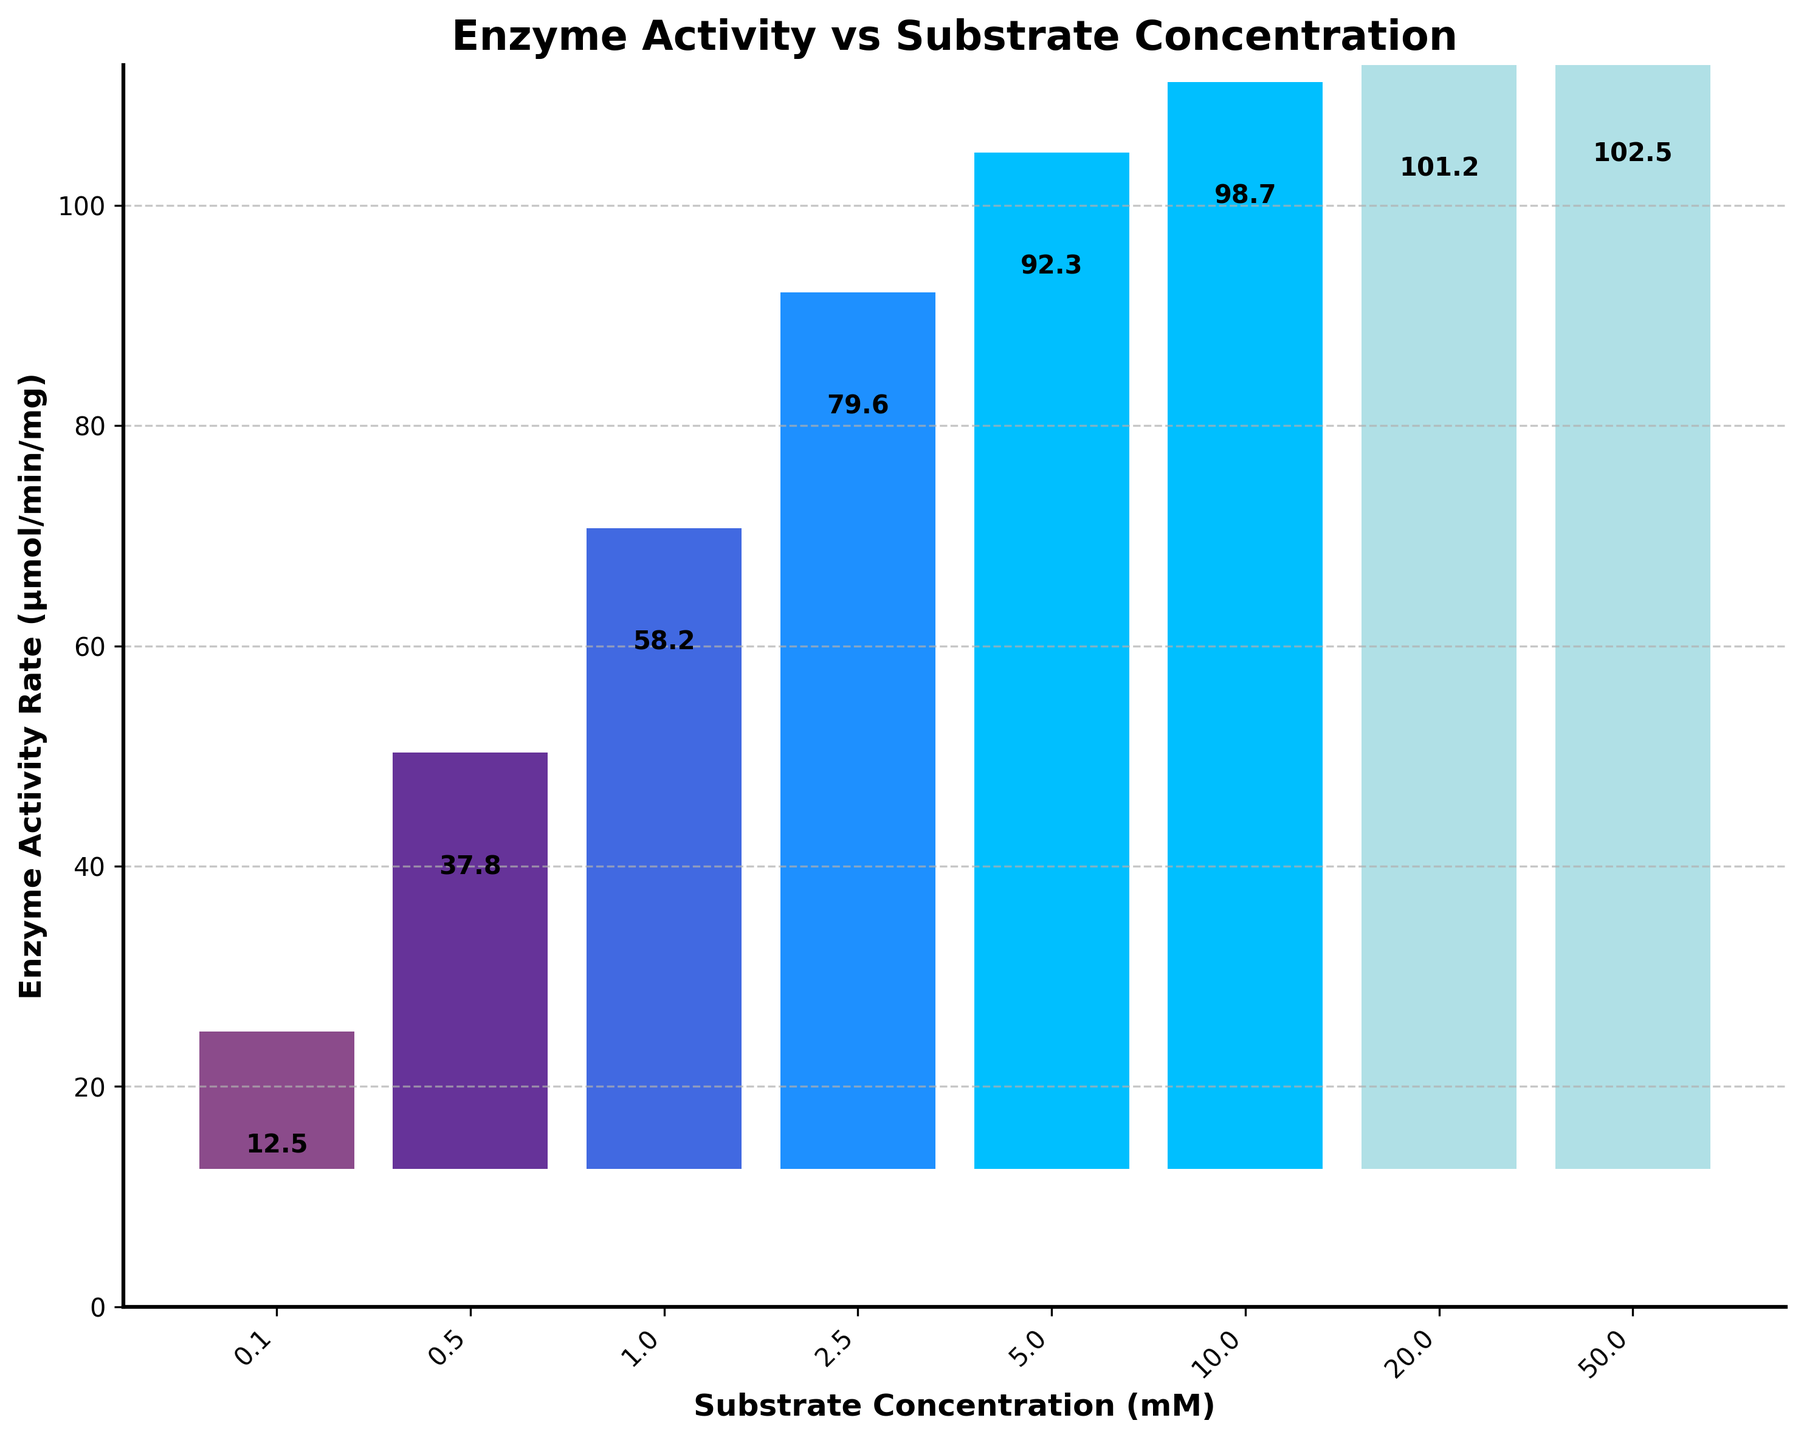What is the title of the figure? The title of the figure is displayed at the top of the plot and reads "Enzyme Activity vs Substrate Concentration".
Answer: Enzyme Activity vs Substrate Concentration What are the units of the x-axis and y-axis? The units for the x-axis are "mM" (millimolar, representing substrate concentration), and for the y-axis are "μmol/min/mg" (micromoles per minute per milligram, representing enzyme activity rate).
Answer: mM and μmol/min/mg How many data points are there in total? Count the number of bars on the chart, each representing a data point for specific substrate concentration and enzyme activity rate.
Answer: 8 Which substrate concentration shows the highest enzyme activity rate? Identify the bar with the highest position along the y-axis. According to the figure, the highest enzyme activity rate occurs at the substrate concentration of 50.0 mM.
Answer: 50.0 mM What is the range of enzyme activity rates displayed? Examine the lowest and highest values on the y-axis; the range is from the lowest enzyme activity rate (12.5 μmol/min/mg at 0.1 mM) to the highest enzyme activity rate (102.5 μmol/min/mg at 50.0 mM).
Answer: 12.5 to 102.5 μmol/min/mg What is the difference in enzyme activity rates between the lowest and highest substrate concentrations? Locate the enzyme activity rates for the lowest substrate concentration (0.1 mM) and the highest substrate concentration (50.0 mM), then subtract the former from the latter (102.5 - 12.5).
Answer: 90.0 μmol/min/mg Which two consecutive substrate concentrations show the largest increase in enzyme activity? Compare the increase in enzyme activity between consecutive substrate concentrations to determine where the largest increase occurs. The largest increase is between 0.1 mM (12.5) and 0.5 mM (37.8), an increase of (37.8 - 12.5).
Answer: 0.1 mM to 0.5 mM Is there any substrate concentration point after which enzyme activity rate does not significantly increase? Identify a point where the increases in enzyme activity rate become minimal or plateau. After 10.0 mM (98.7 μmol/min/mg), the activity rate shows minimal increase, reaching a maximum around 50.0 mM (102.5 μmol/min/mg).
Answer: Yes, after 10.0 mM What is the average enzyme activity rate for substrate concentrations less than or equal to 5.0 mM? Calculate the average by summing the enzyme activity rates for concentrations 0.1, 0.5, 1.0, 2.5, and 5.0 mM and then dividing by the number of these concentrations: (12.5 + 37.8 + 58.2 + 79.6 + 92.3) / 5.
Answer: 56.08 μmol/min/mg 